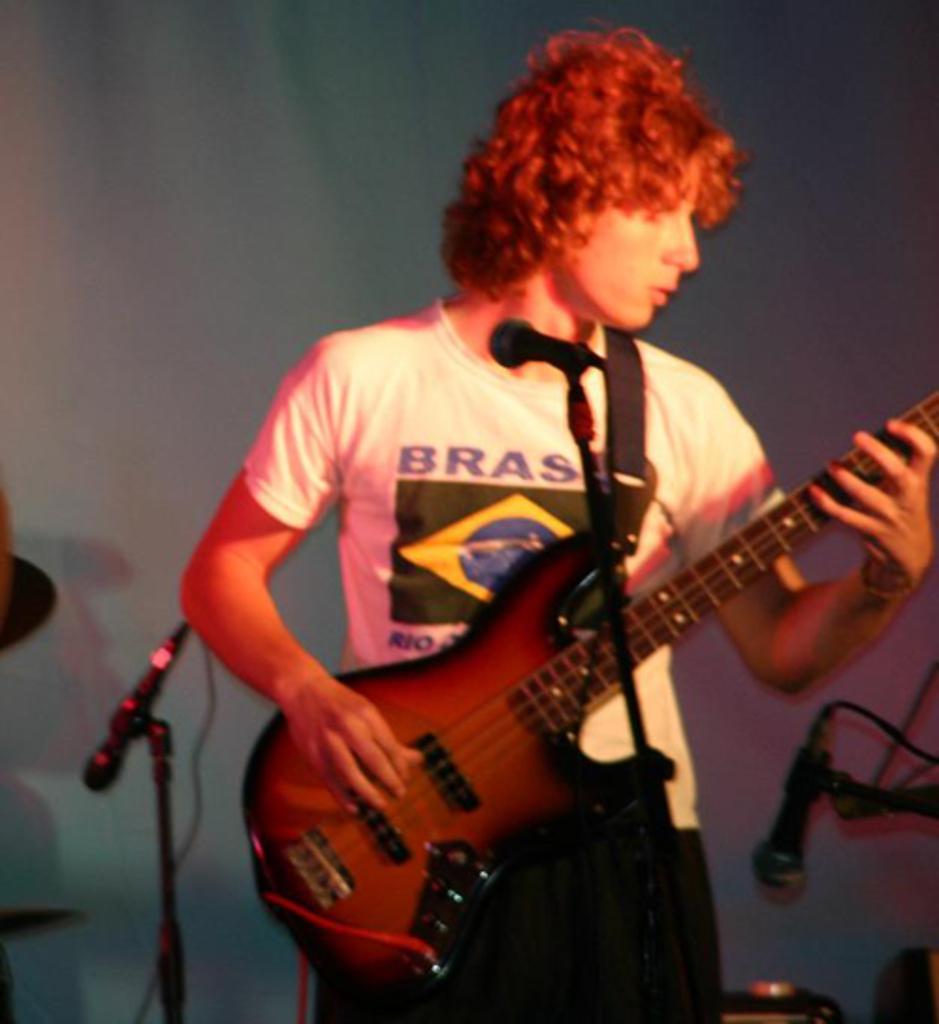Please provide a concise description of this image. Here we can see one man standing in front of a mike and playing guitar. These are mike's. 